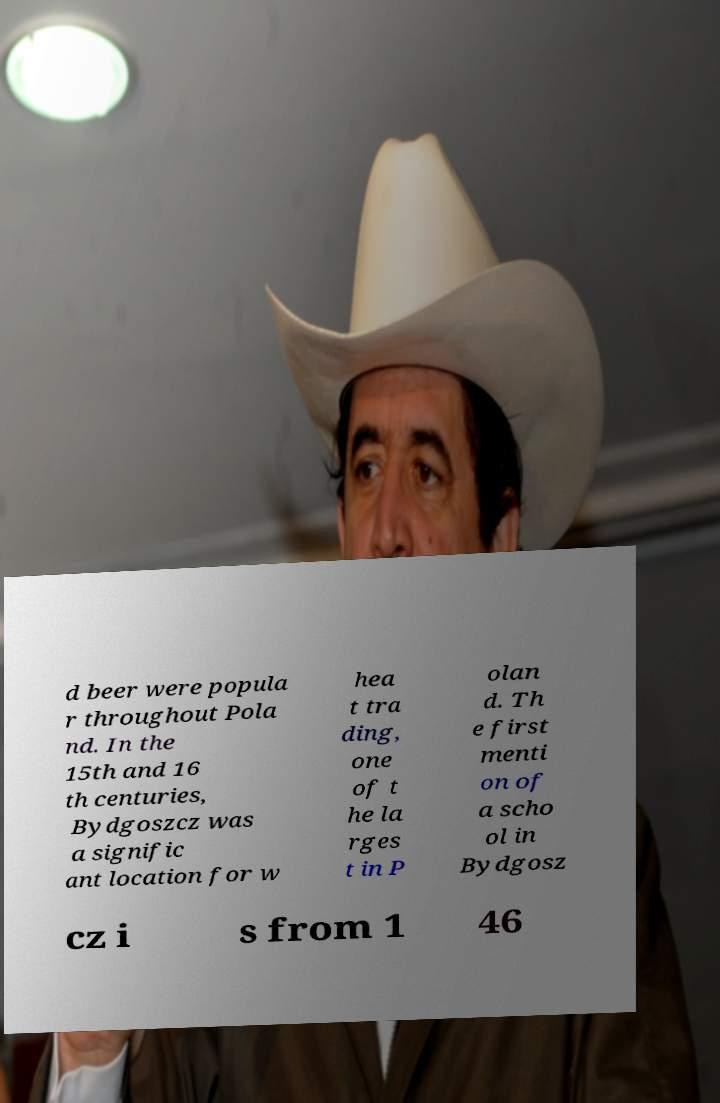There's text embedded in this image that I need extracted. Can you transcribe it verbatim? d beer were popula r throughout Pola nd. In the 15th and 16 th centuries, Bydgoszcz was a signific ant location for w hea t tra ding, one of t he la rges t in P olan d. Th e first menti on of a scho ol in Bydgosz cz i s from 1 46 